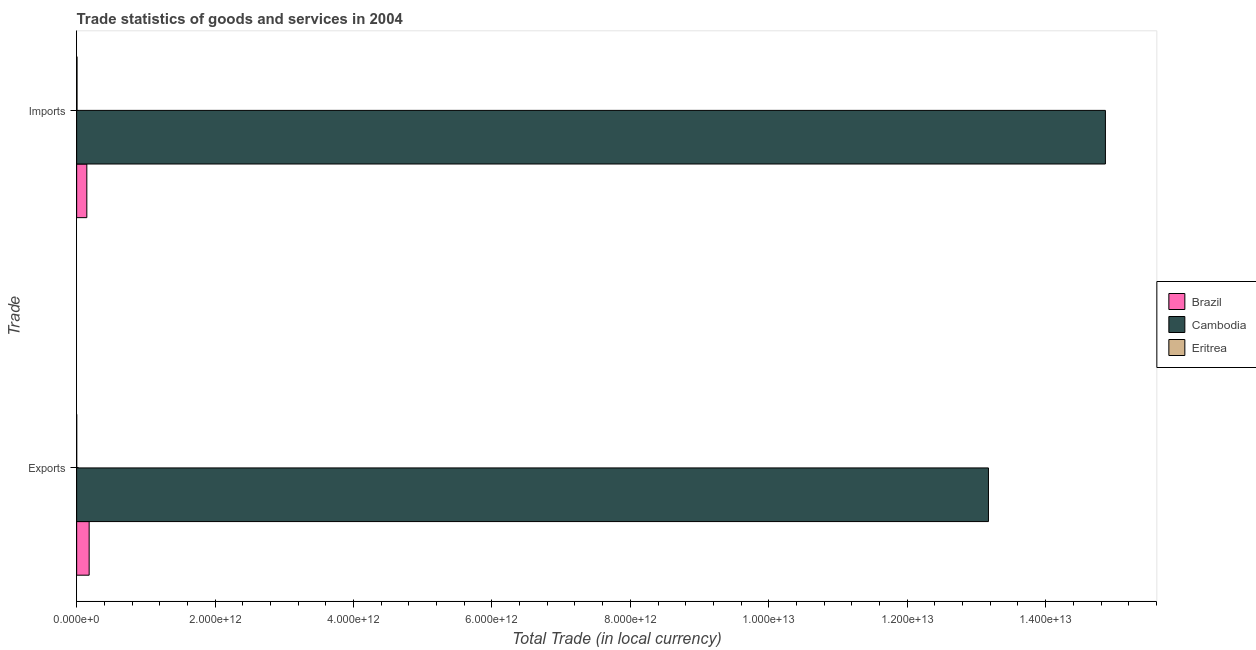How many different coloured bars are there?
Provide a short and direct response. 3. How many groups of bars are there?
Keep it short and to the point. 2. Are the number of bars per tick equal to the number of legend labels?
Offer a terse response. Yes. Are the number of bars on each tick of the Y-axis equal?
Give a very brief answer. Yes. How many bars are there on the 1st tick from the top?
Provide a short and direct response. 3. What is the label of the 2nd group of bars from the top?
Your answer should be very brief. Exports. What is the imports of goods and services in Brazil?
Offer a very short reply. 1.47e+11. Across all countries, what is the maximum export of goods and services?
Give a very brief answer. 1.32e+13. Across all countries, what is the minimum export of goods and services?
Offer a terse response. 6.85e+08. In which country was the export of goods and services maximum?
Your answer should be compact. Cambodia. In which country was the imports of goods and services minimum?
Your answer should be very brief. Eritrea. What is the total export of goods and services in the graph?
Your answer should be very brief. 1.34e+13. What is the difference between the imports of goods and services in Cambodia and that in Eritrea?
Offer a terse response. 1.49e+13. What is the difference between the imports of goods and services in Eritrea and the export of goods and services in Brazil?
Make the answer very short. -1.75e+11. What is the average export of goods and services per country?
Offer a very short reply. 4.45e+12. What is the difference between the imports of goods and services and export of goods and services in Eritrea?
Provide a short and direct response. 4.67e+09. What is the ratio of the imports of goods and services in Eritrea to that in Brazil?
Keep it short and to the point. 0.04. Is the export of goods and services in Brazil less than that in Eritrea?
Offer a very short reply. No. What does the 1st bar from the top in Imports represents?
Your answer should be compact. Eritrea. What is the difference between two consecutive major ticks on the X-axis?
Ensure brevity in your answer.  2.00e+12. Does the graph contain any zero values?
Keep it short and to the point. No. Does the graph contain grids?
Ensure brevity in your answer.  No. How many legend labels are there?
Make the answer very short. 3. What is the title of the graph?
Offer a very short reply. Trade statistics of goods and services in 2004. Does "Europe(all income levels)" appear as one of the legend labels in the graph?
Your answer should be compact. No. What is the label or title of the X-axis?
Your response must be concise. Total Trade (in local currency). What is the label or title of the Y-axis?
Your answer should be compact. Trade. What is the Total Trade (in local currency) in Brazil in Exports?
Ensure brevity in your answer.  1.81e+11. What is the Total Trade (in local currency) of Cambodia in Exports?
Your answer should be very brief. 1.32e+13. What is the Total Trade (in local currency) of Eritrea in Exports?
Ensure brevity in your answer.  6.85e+08. What is the Total Trade (in local currency) in Brazil in Imports?
Give a very brief answer. 1.47e+11. What is the Total Trade (in local currency) in Cambodia in Imports?
Offer a terse response. 1.49e+13. What is the Total Trade (in local currency) of Eritrea in Imports?
Give a very brief answer. 5.35e+09. Across all Trade, what is the maximum Total Trade (in local currency) in Brazil?
Your answer should be compact. 1.81e+11. Across all Trade, what is the maximum Total Trade (in local currency) in Cambodia?
Keep it short and to the point. 1.49e+13. Across all Trade, what is the maximum Total Trade (in local currency) of Eritrea?
Provide a succinct answer. 5.35e+09. Across all Trade, what is the minimum Total Trade (in local currency) in Brazil?
Make the answer very short. 1.47e+11. Across all Trade, what is the minimum Total Trade (in local currency) of Cambodia?
Offer a terse response. 1.32e+13. Across all Trade, what is the minimum Total Trade (in local currency) of Eritrea?
Make the answer very short. 6.85e+08. What is the total Total Trade (in local currency) in Brazil in the graph?
Keep it short and to the point. 3.27e+11. What is the total Total Trade (in local currency) in Cambodia in the graph?
Make the answer very short. 2.80e+13. What is the total Total Trade (in local currency) in Eritrea in the graph?
Your answer should be compact. 6.04e+09. What is the difference between the Total Trade (in local currency) in Brazil in Exports and that in Imports?
Your answer should be very brief. 3.36e+1. What is the difference between the Total Trade (in local currency) of Cambodia in Exports and that in Imports?
Keep it short and to the point. -1.69e+12. What is the difference between the Total Trade (in local currency) in Eritrea in Exports and that in Imports?
Your answer should be very brief. -4.67e+09. What is the difference between the Total Trade (in local currency) of Brazil in Exports and the Total Trade (in local currency) of Cambodia in Imports?
Your answer should be very brief. -1.47e+13. What is the difference between the Total Trade (in local currency) in Brazil in Exports and the Total Trade (in local currency) in Eritrea in Imports?
Keep it short and to the point. 1.75e+11. What is the difference between the Total Trade (in local currency) of Cambodia in Exports and the Total Trade (in local currency) of Eritrea in Imports?
Make the answer very short. 1.32e+13. What is the average Total Trade (in local currency) in Brazil per Trade?
Provide a succinct answer. 1.64e+11. What is the average Total Trade (in local currency) of Cambodia per Trade?
Offer a very short reply. 1.40e+13. What is the average Total Trade (in local currency) in Eritrea per Trade?
Make the answer very short. 3.02e+09. What is the difference between the Total Trade (in local currency) in Brazil and Total Trade (in local currency) in Cambodia in Exports?
Offer a very short reply. -1.30e+13. What is the difference between the Total Trade (in local currency) of Brazil and Total Trade (in local currency) of Eritrea in Exports?
Your response must be concise. 1.80e+11. What is the difference between the Total Trade (in local currency) of Cambodia and Total Trade (in local currency) of Eritrea in Exports?
Your answer should be very brief. 1.32e+13. What is the difference between the Total Trade (in local currency) of Brazil and Total Trade (in local currency) of Cambodia in Imports?
Give a very brief answer. -1.47e+13. What is the difference between the Total Trade (in local currency) in Brazil and Total Trade (in local currency) in Eritrea in Imports?
Provide a succinct answer. 1.42e+11. What is the difference between the Total Trade (in local currency) in Cambodia and Total Trade (in local currency) in Eritrea in Imports?
Offer a terse response. 1.49e+13. What is the ratio of the Total Trade (in local currency) of Brazil in Exports to that in Imports?
Give a very brief answer. 1.23. What is the ratio of the Total Trade (in local currency) of Cambodia in Exports to that in Imports?
Your response must be concise. 0.89. What is the ratio of the Total Trade (in local currency) of Eritrea in Exports to that in Imports?
Provide a succinct answer. 0.13. What is the difference between the highest and the second highest Total Trade (in local currency) of Brazil?
Offer a very short reply. 3.36e+1. What is the difference between the highest and the second highest Total Trade (in local currency) in Cambodia?
Keep it short and to the point. 1.69e+12. What is the difference between the highest and the second highest Total Trade (in local currency) of Eritrea?
Keep it short and to the point. 4.67e+09. What is the difference between the highest and the lowest Total Trade (in local currency) in Brazil?
Your answer should be compact. 3.36e+1. What is the difference between the highest and the lowest Total Trade (in local currency) in Cambodia?
Keep it short and to the point. 1.69e+12. What is the difference between the highest and the lowest Total Trade (in local currency) in Eritrea?
Your answer should be very brief. 4.67e+09. 